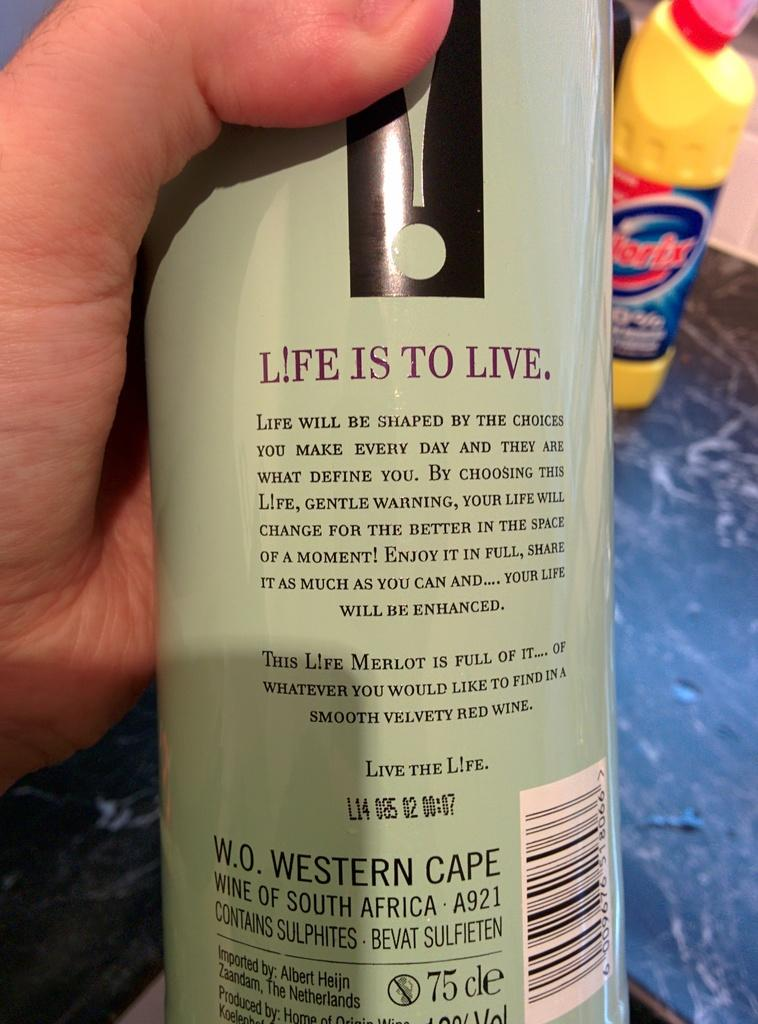<image>
Present a compact description of the photo's key features. A bottle that claims Life is to live. 